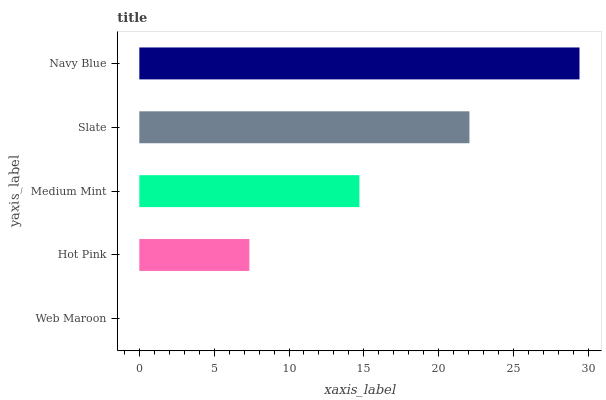Is Web Maroon the minimum?
Answer yes or no. Yes. Is Navy Blue the maximum?
Answer yes or no. Yes. Is Hot Pink the minimum?
Answer yes or no. No. Is Hot Pink the maximum?
Answer yes or no. No. Is Hot Pink greater than Web Maroon?
Answer yes or no. Yes. Is Web Maroon less than Hot Pink?
Answer yes or no. Yes. Is Web Maroon greater than Hot Pink?
Answer yes or no. No. Is Hot Pink less than Web Maroon?
Answer yes or no. No. Is Medium Mint the high median?
Answer yes or no. Yes. Is Medium Mint the low median?
Answer yes or no. Yes. Is Web Maroon the high median?
Answer yes or no. No. Is Slate the low median?
Answer yes or no. No. 